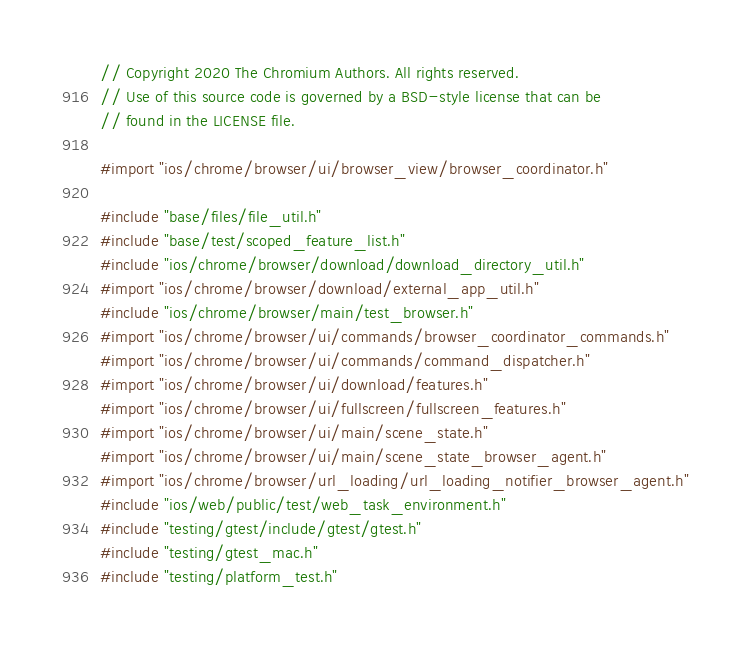<code> <loc_0><loc_0><loc_500><loc_500><_ObjectiveC_>// Copyright 2020 The Chromium Authors. All rights reserved.
// Use of this source code is governed by a BSD-style license that can be
// found in the LICENSE file.

#import "ios/chrome/browser/ui/browser_view/browser_coordinator.h"

#include "base/files/file_util.h"
#include "base/test/scoped_feature_list.h"
#include "ios/chrome/browser/download/download_directory_util.h"
#import "ios/chrome/browser/download/external_app_util.h"
#include "ios/chrome/browser/main/test_browser.h"
#import "ios/chrome/browser/ui/commands/browser_coordinator_commands.h"
#import "ios/chrome/browser/ui/commands/command_dispatcher.h"
#import "ios/chrome/browser/ui/download/features.h"
#import "ios/chrome/browser/ui/fullscreen/fullscreen_features.h"
#import "ios/chrome/browser/ui/main/scene_state.h"
#import "ios/chrome/browser/ui/main/scene_state_browser_agent.h"
#import "ios/chrome/browser/url_loading/url_loading_notifier_browser_agent.h"
#include "ios/web/public/test/web_task_environment.h"
#include "testing/gtest/include/gtest/gtest.h"
#include "testing/gtest_mac.h"
#include "testing/platform_test.h"</code> 